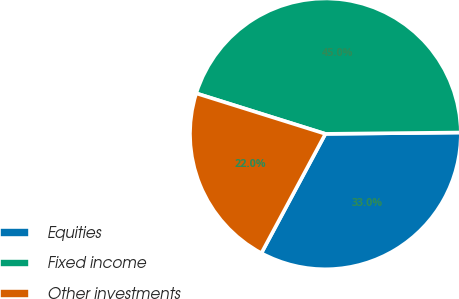Convert chart. <chart><loc_0><loc_0><loc_500><loc_500><pie_chart><fcel>Equities<fcel>Fixed income<fcel>Other investments<nl><fcel>33.0%<fcel>45.0%<fcel>22.0%<nl></chart> 